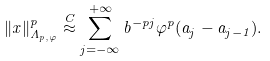<formula> <loc_0><loc_0><loc_500><loc_500>\| x \| _ { \Lambda _ { p , \varphi } } ^ { p } \stackrel { C } { \approx } \sum _ { j = - \infty } ^ { + \infty } b ^ { - p j } \varphi ^ { p } ( a _ { j } - a _ { j - 1 } ) .</formula> 